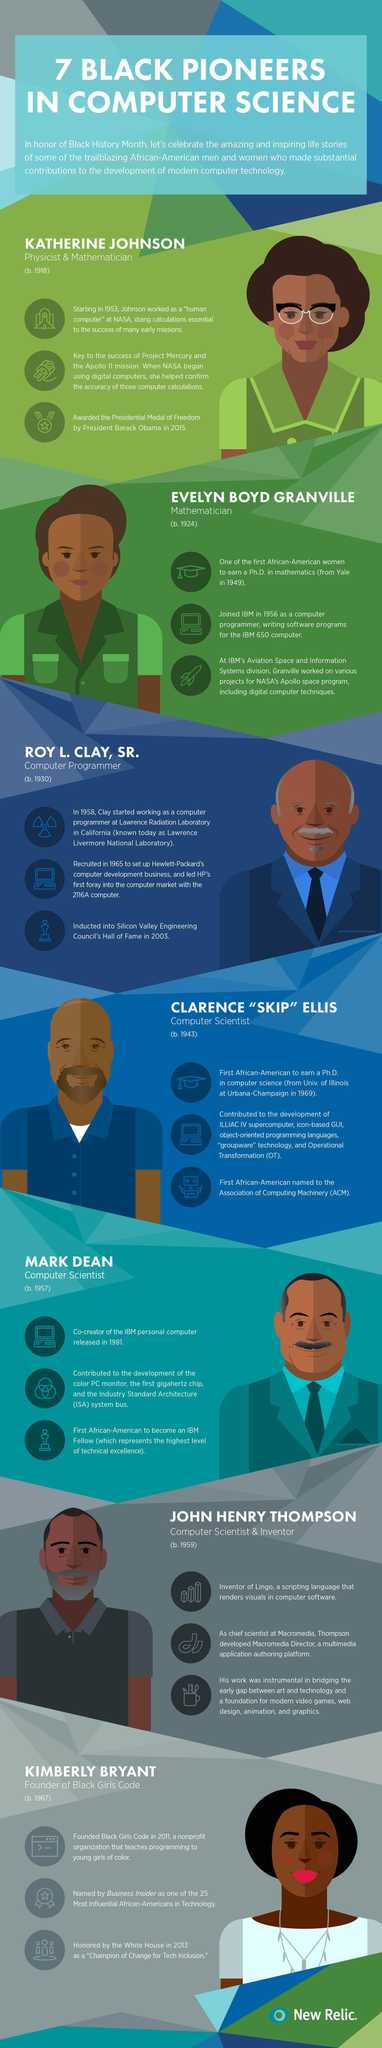Draw attention to some important aspects in this diagram. The infographic features 4 men. There are three women featured in this infographic. This infographic features a total of 3 computer scientists. 